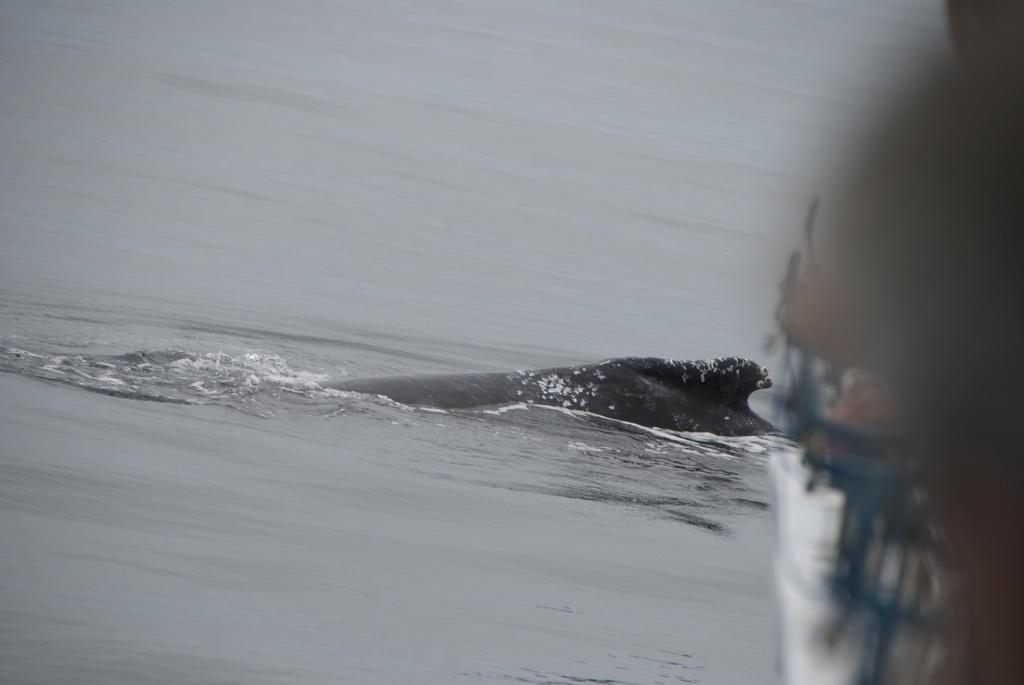What type of animal is in the image? There is a fish in the image. Where is the fish located? The fish is in the water. What type of clover is growing near the fish in the image? There is no clover present in the image; it features a fish in the water. Can you describe the icicle hanging from the fish's mouth in the image? There is no icicle present in the image; it only shows a fish in the water. 